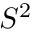Convert formula to latex. <formula><loc_0><loc_0><loc_500><loc_500>S ^ { 2 }</formula> 